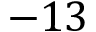<formula> <loc_0><loc_0><loc_500><loc_500>- 1 3</formula> 